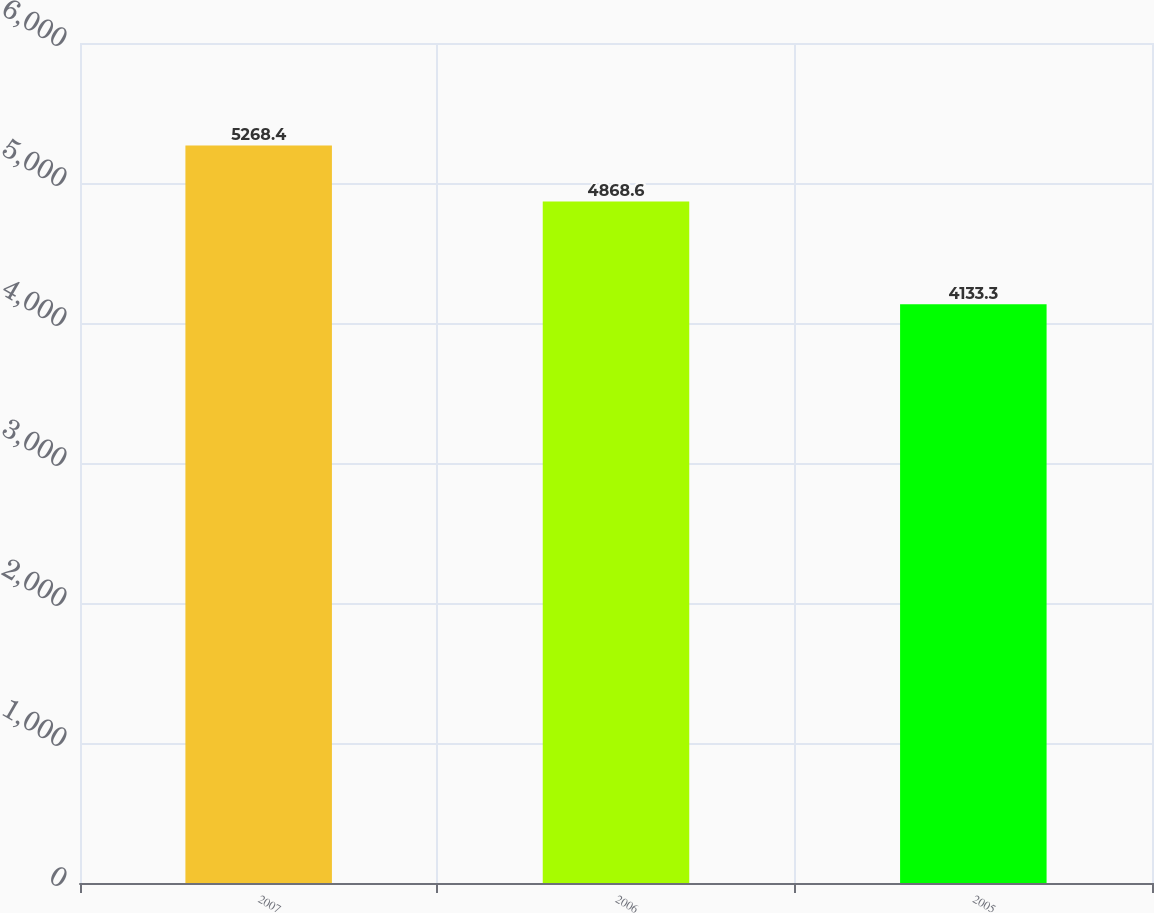Convert chart to OTSL. <chart><loc_0><loc_0><loc_500><loc_500><bar_chart><fcel>2007<fcel>2006<fcel>2005<nl><fcel>5268.4<fcel>4868.6<fcel>4133.3<nl></chart> 